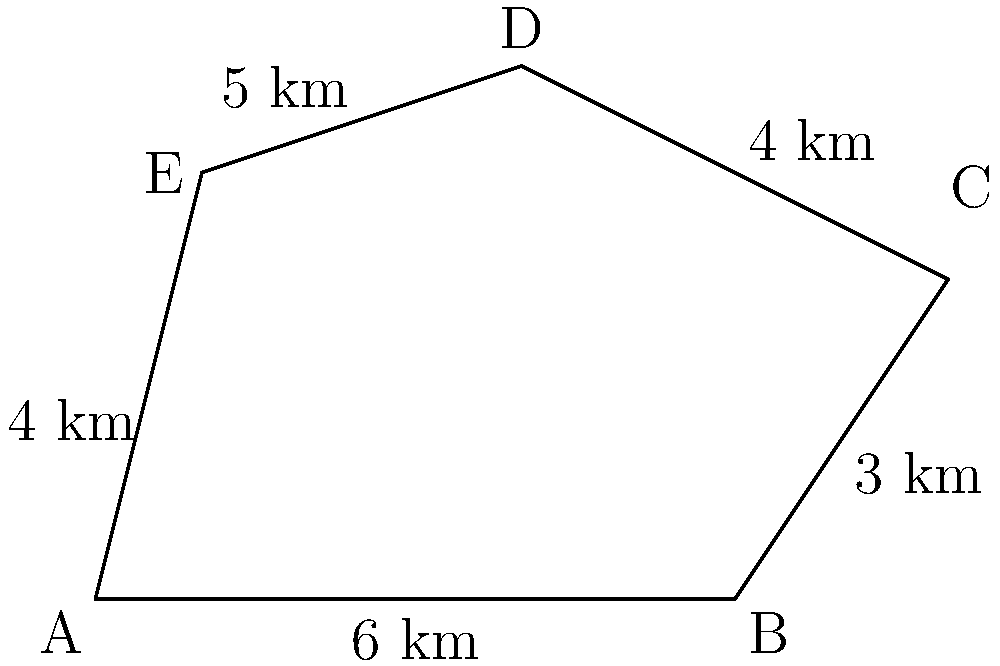Dr. Winkler's latest research focuses on an irregular pentagonal naval base. Given the diagram of the base's layout, where each side represents a fortified wall, calculate the total perimeter of the base. How many kilometers of fortification are needed to completely enclose this strategic location? To find the perimeter of the irregular pentagonal naval base, we need to sum up the lengths of all five sides. Let's break it down step-by-step:

1) Side AB: 6 km
2) Side BC: 3 km
3) Side CD: 4 km
4) Side DE: 5 km
5) Side EA: 4 km

Now, let's add all these lengths:

$$\text{Perimeter} = AB + BC + CD + DE + EA$$
$$\text{Perimeter} = 6 + 3 + 4 + 5 + 4 = 22\text{ km}$$

Therefore, the total perimeter of the naval base is 22 kilometers. This represents the total length of fortification needed to enclose the entire strategic location.
Answer: 22 km 